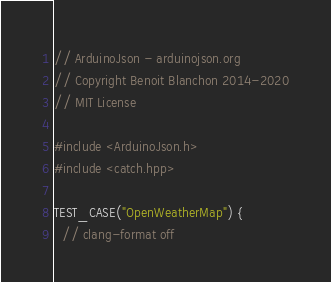<code> <loc_0><loc_0><loc_500><loc_500><_C++_>// ArduinoJson - arduinojson.org
// Copyright Benoit Blanchon 2014-2020
// MIT License

#include <ArduinoJson.h>
#include <catch.hpp>

TEST_CASE("OpenWeatherMap") {
  // clang-format off</code> 